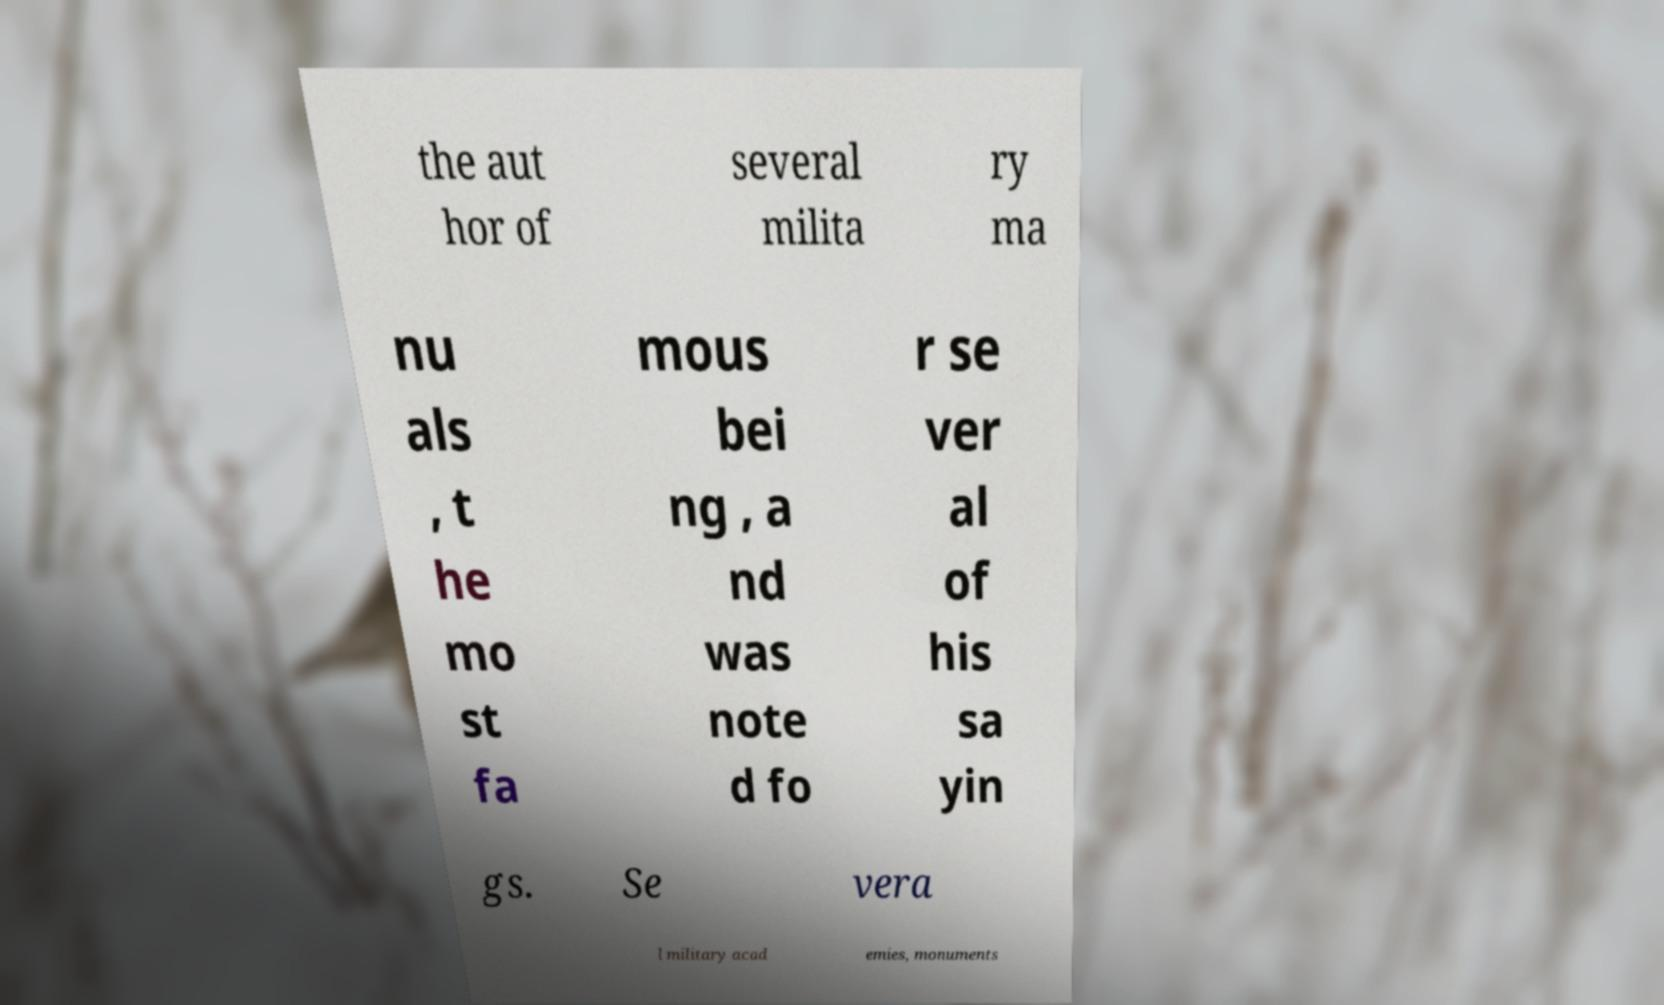Can you accurately transcribe the text from the provided image for me? the aut hor of several milita ry ma nu als , t he mo st fa mous bei ng , a nd was note d fo r se ver al of his sa yin gs. Se vera l military acad emies, monuments 